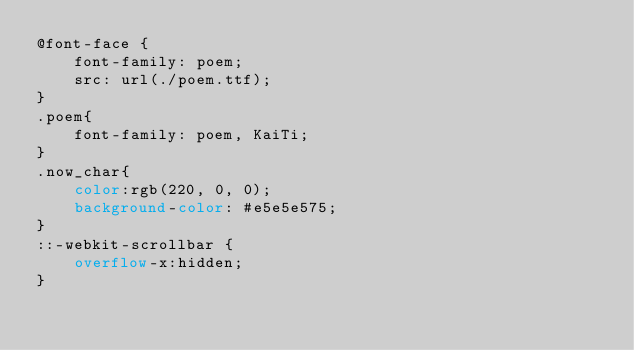Convert code to text. <code><loc_0><loc_0><loc_500><loc_500><_CSS_>@font-face {
    font-family: poem;
    src: url(./poem.ttf);
}
.poem{
    font-family: poem, KaiTi;
}
.now_char{
    color:rgb(220, 0, 0);
    background-color: #e5e5e575;
}
::-webkit-scrollbar {
    overflow-x:hidden;
}</code> 